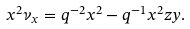Convert formula to latex. <formula><loc_0><loc_0><loc_500><loc_500>x ^ { 2 } \nu _ { x } = q ^ { - 2 } x ^ { 2 } - q ^ { - 1 } x ^ { 2 } z y .</formula> 